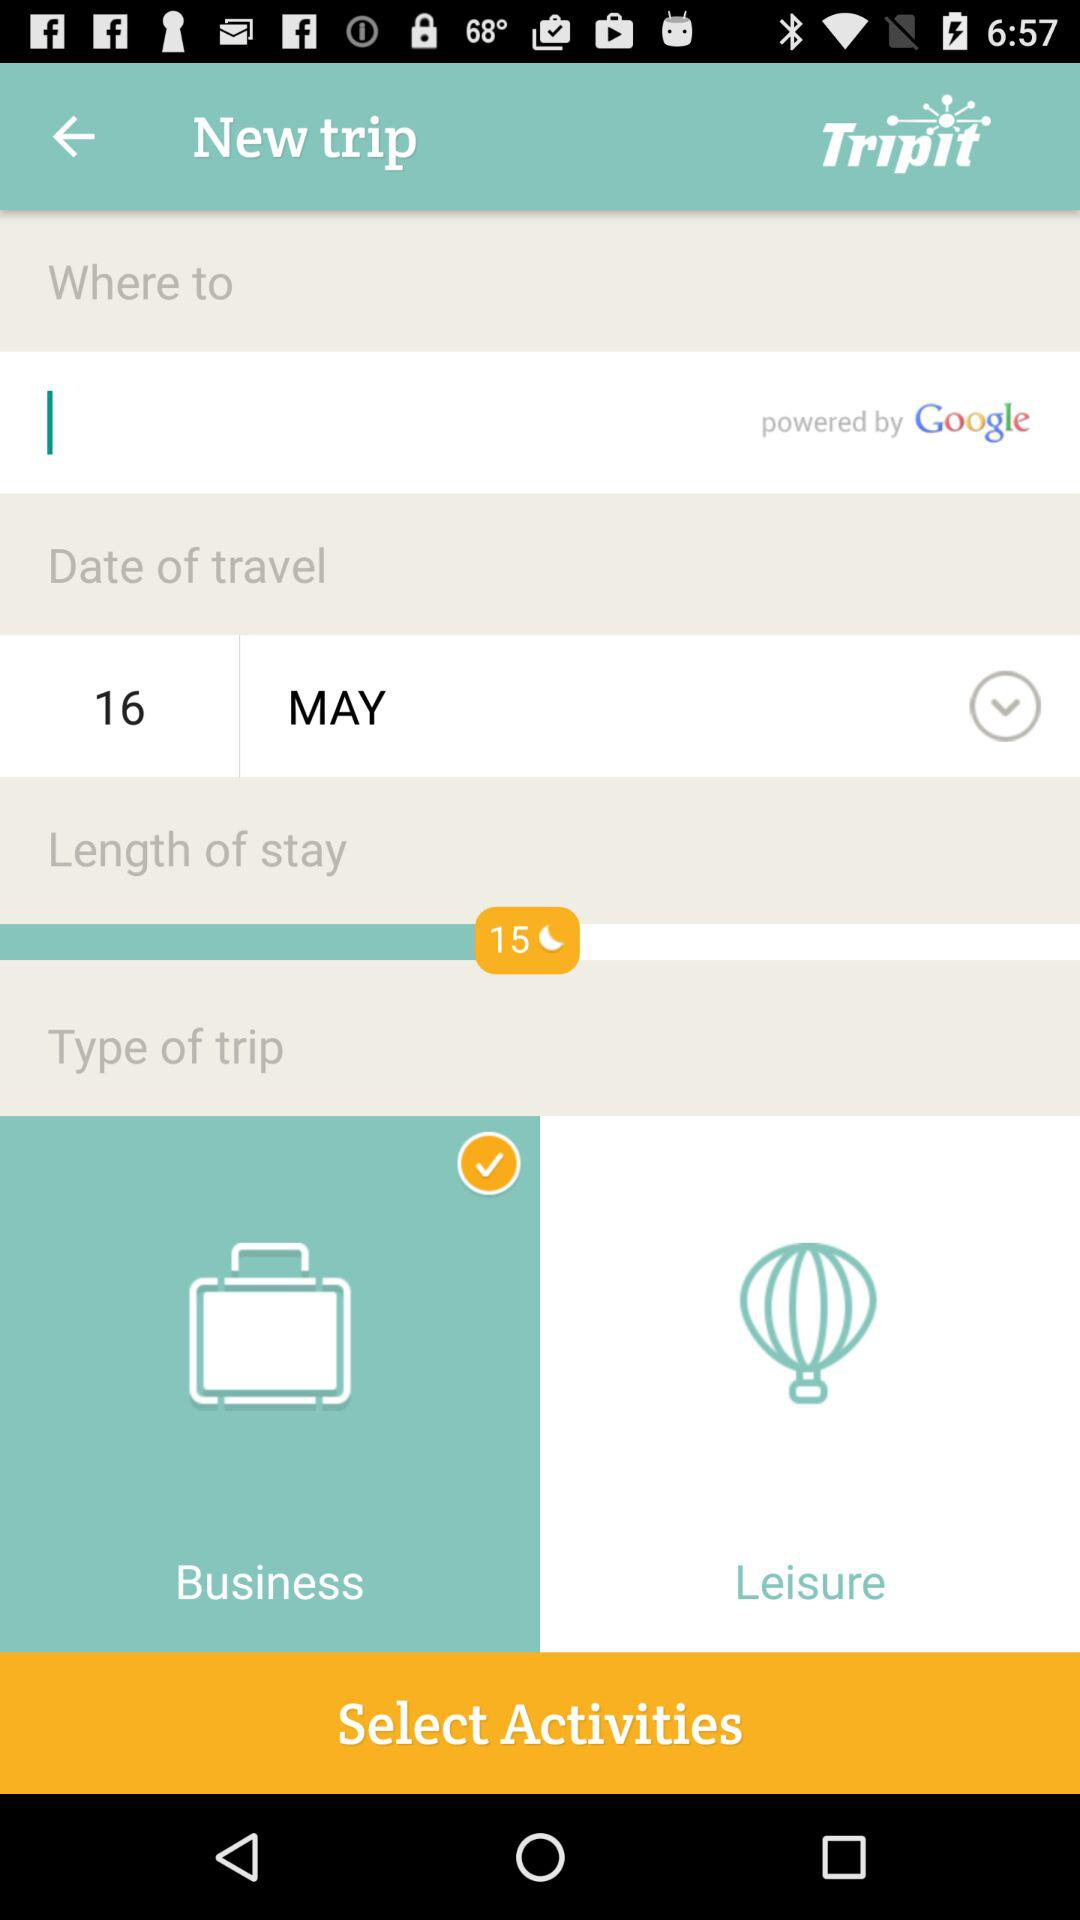What is the length of stay? The length of stay is 15 days. 